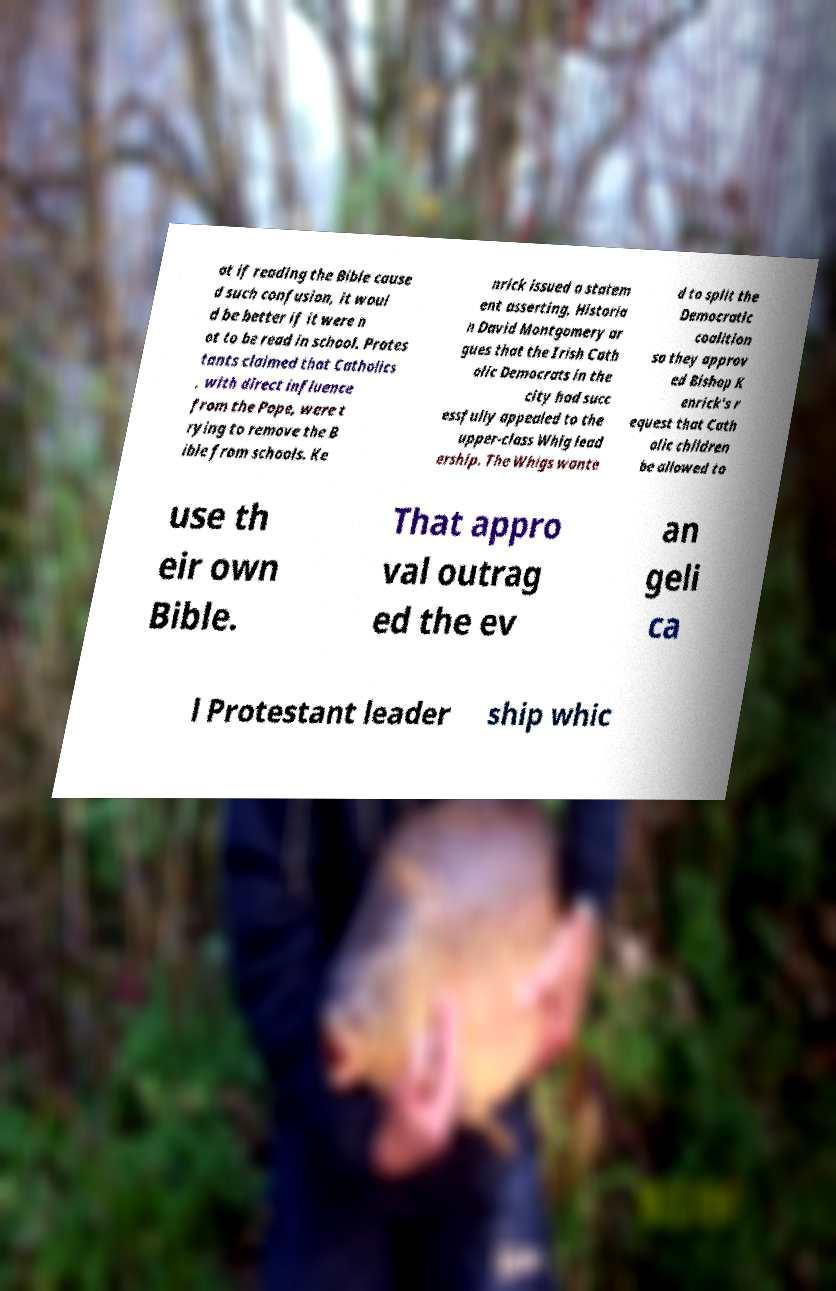I need the written content from this picture converted into text. Can you do that? at if reading the Bible cause d such confusion, it woul d be better if it were n ot to be read in school. Protes tants claimed that Catholics , with direct influence from the Pope, were t rying to remove the B ible from schools. Ke nrick issued a statem ent asserting, Historia n David Montgomery ar gues that the Irish Cath olic Democrats in the city had succ essfully appealed to the upper-class Whig lead ership. The Whigs wante d to split the Democratic coalition so they approv ed Bishop K enrick's r equest that Cath olic children be allowed to use th eir own Bible. That appro val outrag ed the ev an geli ca l Protestant leader ship whic 